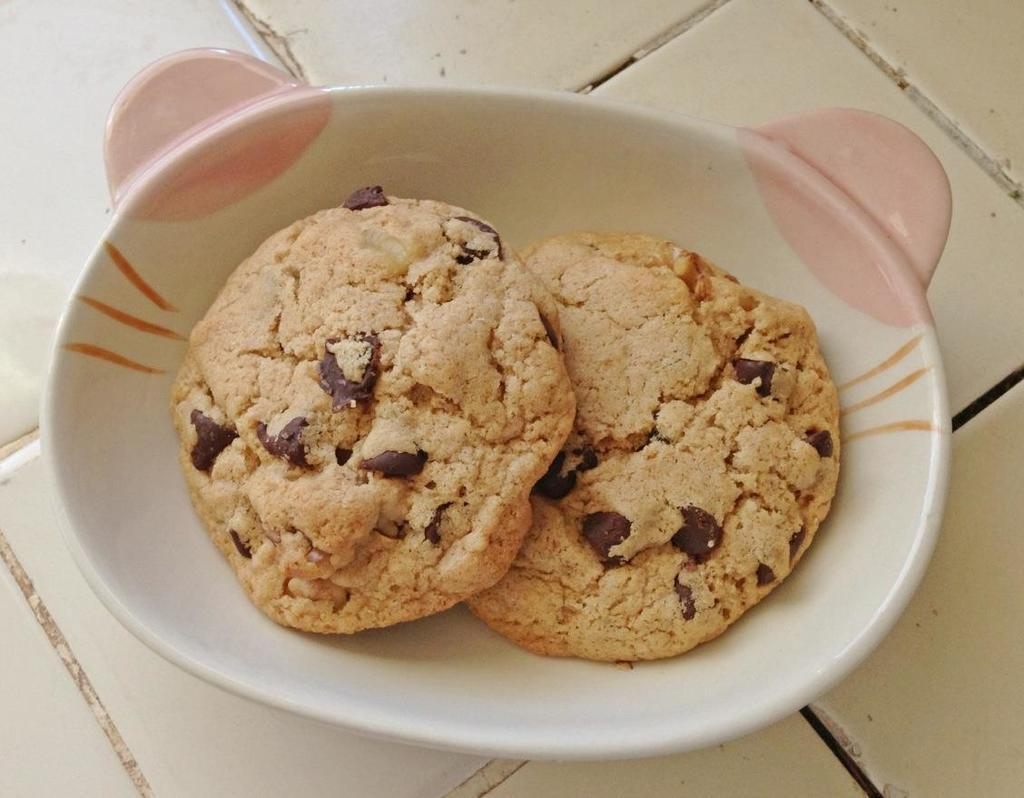What is present in the image related to food? There is food in the image. How is the food arranged or presented? The food is in a plate. What color is the paint on the ring in the image? There is no paint or ring present in the image; it only features food in a plate. 